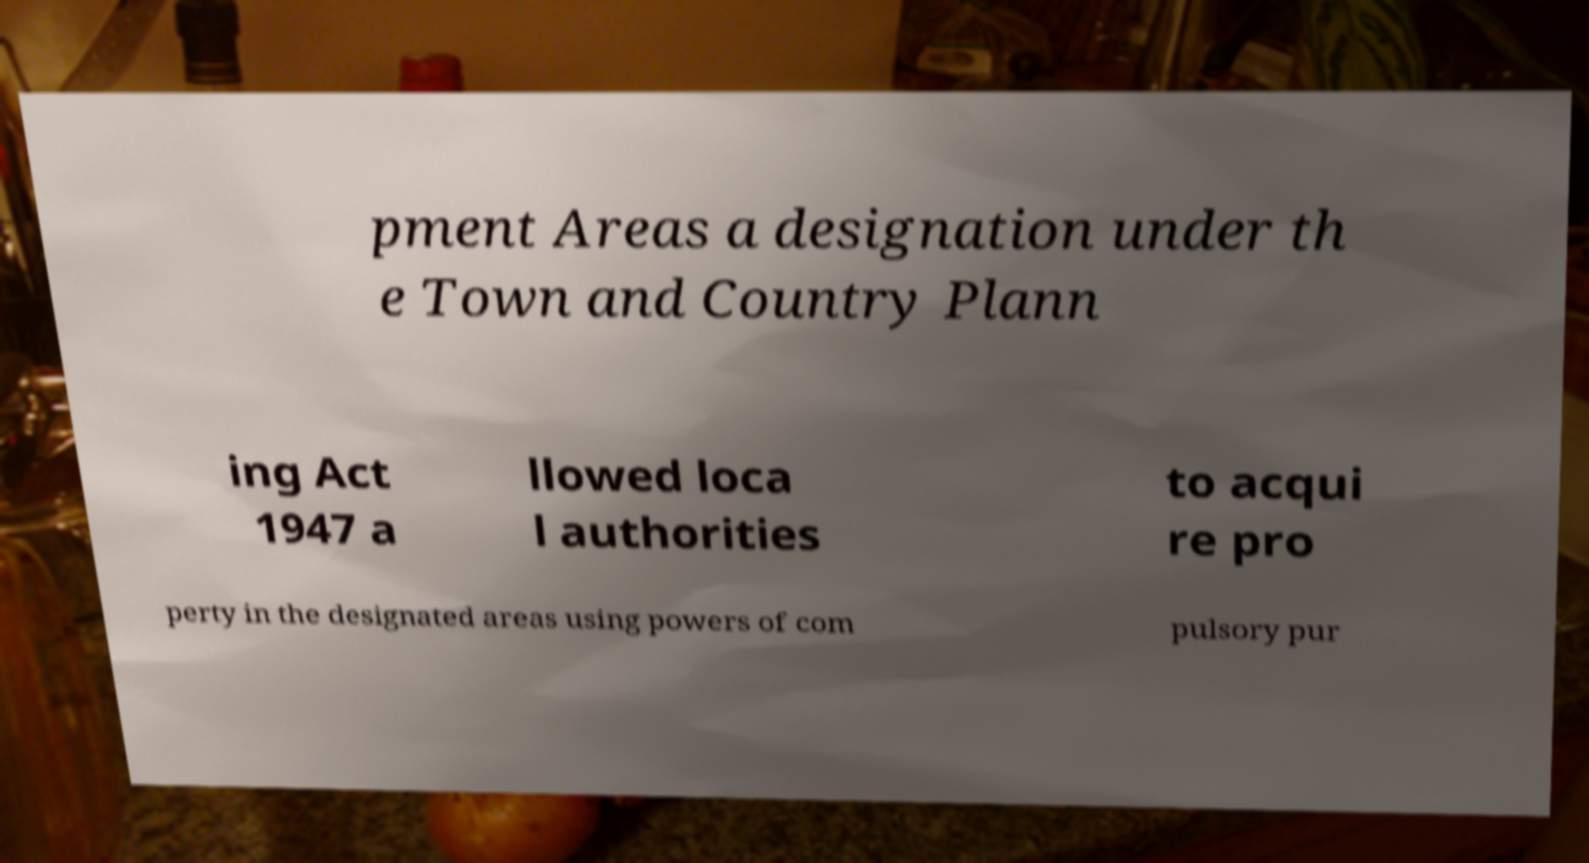Can you accurately transcribe the text from the provided image for me? pment Areas a designation under th e Town and Country Plann ing Act 1947 a llowed loca l authorities to acqui re pro perty in the designated areas using powers of com pulsory pur 